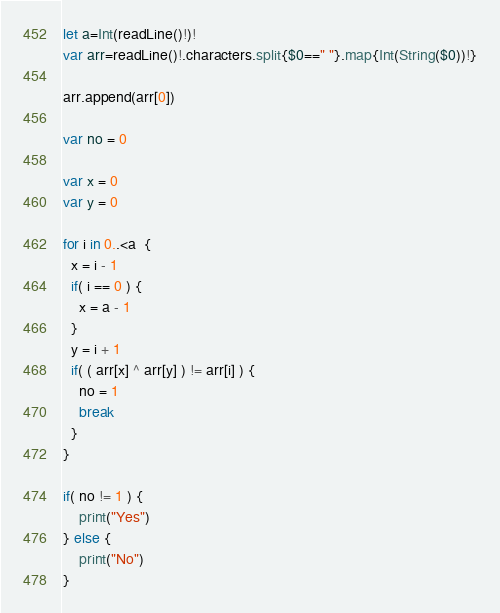Convert code to text. <code><loc_0><loc_0><loc_500><loc_500><_Swift_>let a=Int(readLine()!)!
var arr=readLine()!.characters.split{$0==" "}.map{Int(String($0))!}

arr.append(arr[0])

var no = 0

var x = 0
var y = 0

for i in 0..<a  {
  x = i - 1
  if( i == 0 ) {
    x = a - 1
  }
  y = i + 1
  if( ( arr[x] ^ arr[y] ) != arr[i] ) {
    no = 1
    break
  }
}

if( no != 1 ) {
	print("Yes")
} else {
	print("No")
}</code> 